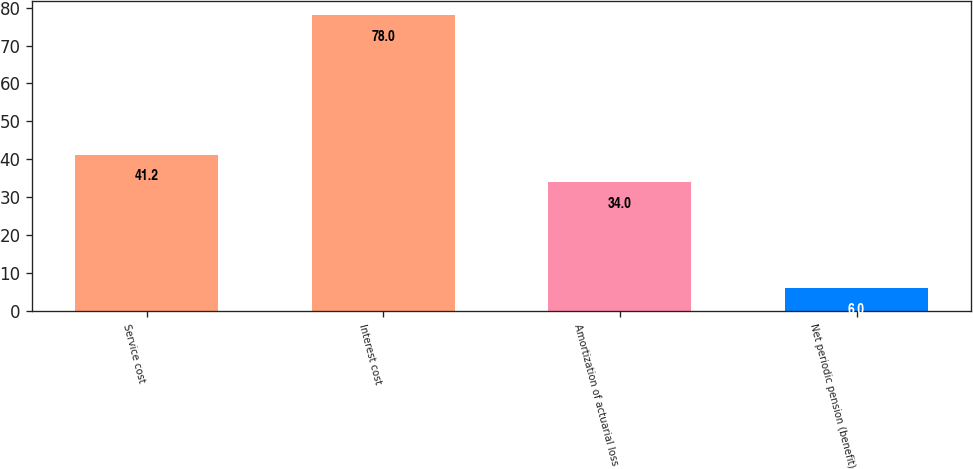Convert chart to OTSL. <chart><loc_0><loc_0><loc_500><loc_500><bar_chart><fcel>Service cost<fcel>Interest cost<fcel>Amortization of actuarial loss<fcel>Net periodic pension (benefit)<nl><fcel>41.2<fcel>78<fcel>34<fcel>6<nl></chart> 